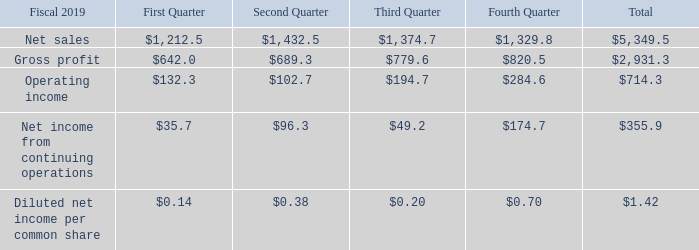Note 21. Quarterly Results (Unaudited)
The following table presents the Company's selected unaudited quarterly operating results for the eight quarters ended March 31, 2019. The Company believes that all adjustments of a normal recurring nature have been made to present fairly the related quarterly results (in millions, except per share amounts). Amounts may not add to the total due to rounding:
Refer to Note 11, Income Taxes, for an explanation of the one-time transition tax recognized in the third quarter of fiscal 2018. Refer to Note 4, Special Charges and Other, Net, for an explanation of the special charges included in operating income in fiscal 2019 and fiscal 2018. Refer to Note 12, Debt and Credit Facility, for an explanation of the loss on settlement of debt included in other (loss) income, net of $4.1 million during the second quarter, $0.2 million during the third quarter, and $8.3 million during the fourth quarter of fiscal 2019 and $13.8 million and $2.1 million for the first quarter and third quarter of fiscal 2018, respectively. Refer to Note 5, Investments, for an explanation of the impairment recognized on available-for-sale securities in the fourth quarter of fiscal 2018.
Why might amounts may not add to the total? Due to rounding. What was the operating income in the first quarter?
Answer scale should be: million. 132.3. What was the total gross profit?
Answer scale should be: million. 2,931.3. What was the change in the gross profit between the first and second quarter?
Answer scale should be: million. 689.3-642.0
Answer: 47.3. What was the difference between the total net sales and gross profit?
Answer scale should be: million. 5,349.5-2,931.3
Answer: 2418.2. What was the percentage change in the Operating income between the third and fourth quarter?
Answer scale should be: percent. (284.6-194.7)/194.7
Answer: 46.17. 